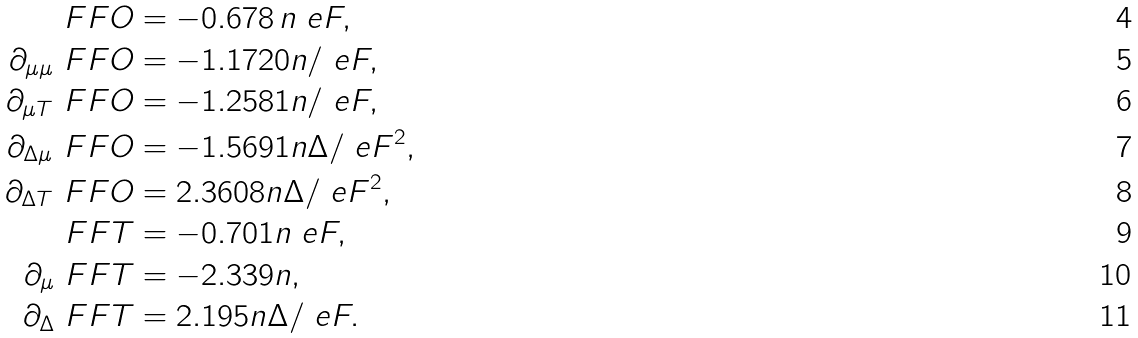Convert formula to latex. <formula><loc_0><loc_0><loc_500><loc_500>\ F F O & = - 0 . 6 7 8 \, n \ e F , \\ \partial _ { \mu \mu } \ F F O & = - 1 . 1 7 2 0 n / \ e F , \\ \partial _ { \mu T } \ F F O & = - 1 . 2 5 8 1 n / \ e F , \\ \partial _ { \Delta \mu } \ F F O & = - 1 . 5 6 9 1 n \Delta / \ e F ^ { 2 } , \\ \partial _ { \Delta T } \ F F O & = 2 . 3 6 0 8 n \Delta / \ e F ^ { 2 } , \\ \ F F T & = - 0 . 7 0 1 n \ e F , \\ \partial _ { \mu } \ F F T & = - 2 . 3 3 9 n , \\ \partial _ { \Delta } \ F F T & = 2 . 1 9 5 n \Delta / \ e F .</formula> 